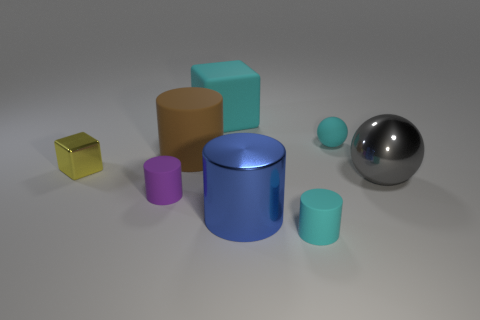What size is the matte block that is the same color as the tiny matte ball?
Provide a succinct answer. Large. Do the object that is behind the cyan rubber ball and the tiny ball have the same color?
Offer a very short reply. Yes. Is there a small rubber object of the same color as the small sphere?
Give a very brief answer. Yes. What number of tiny cyan things are in front of the brown rubber cylinder and to the right of the cyan matte cylinder?
Offer a very short reply. 0. There is a cyan thing that is to the right of the matte cylinder that is right of the big cyan matte cube; what size is it?
Provide a short and direct response. Small. Are there fewer large cyan matte cubes that are behind the cyan matte block than small yellow metal blocks behind the blue metallic cylinder?
Ensure brevity in your answer.  Yes. Does the big matte object that is to the right of the big rubber cylinder have the same color as the large sphere that is right of the yellow metal object?
Your answer should be compact. No. There is a thing that is on the right side of the small cyan rubber cylinder and to the left of the gray sphere; what is its material?
Offer a very short reply. Rubber. Are there any big cyan matte blocks?
Provide a short and direct response. Yes. There is a gray object that is made of the same material as the small cube; what is its shape?
Your answer should be very brief. Sphere. 